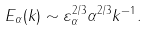Convert formula to latex. <formula><loc_0><loc_0><loc_500><loc_500>E _ { \alpha } ( k ) \sim \varepsilon _ { \alpha } ^ { 2 / 3 } \alpha ^ { 2 / 3 } k ^ { - 1 } .</formula> 